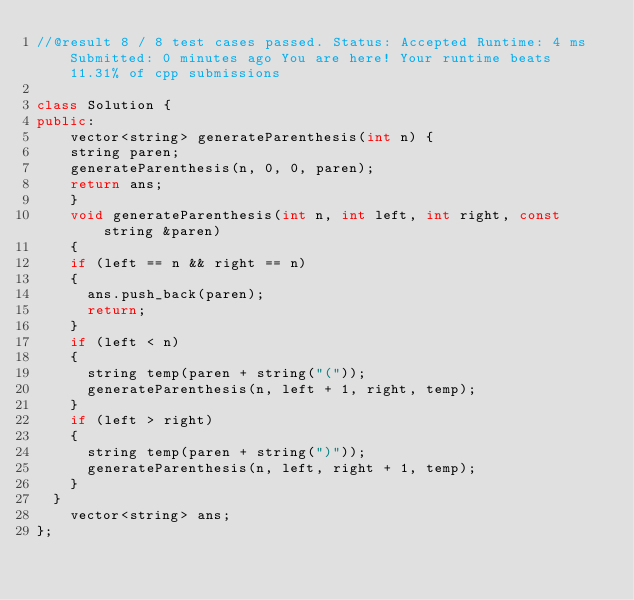Convert code to text. <code><loc_0><loc_0><loc_500><loc_500><_C++_>//@result 8 / 8 test cases passed. Status: Accepted Runtime: 4 ms Submitted: 0 minutes ago You are here! Your runtime beats 11.31% of cpp submissions

class Solution {
public:
    vector<string> generateParenthesis(int n) {
		string paren;
		generateParenthesis(n, 0, 0, paren);
		return ans;
    }
    void generateParenthesis(int n, int left, int right, const string &paren)
    {
		if (left == n && right == n)
		{
			ans.push_back(paren);
			return;
		}
		if (left < n)
		{
			string temp(paren + string("("));
			generateParenthesis(n, left + 1, right, temp);
		}
		if (left > right)
		{
			string temp(paren + string(")"));
			generateParenthesis(n, left, right + 1, temp);
		}
	}
    vector<string> ans;
};
</code> 